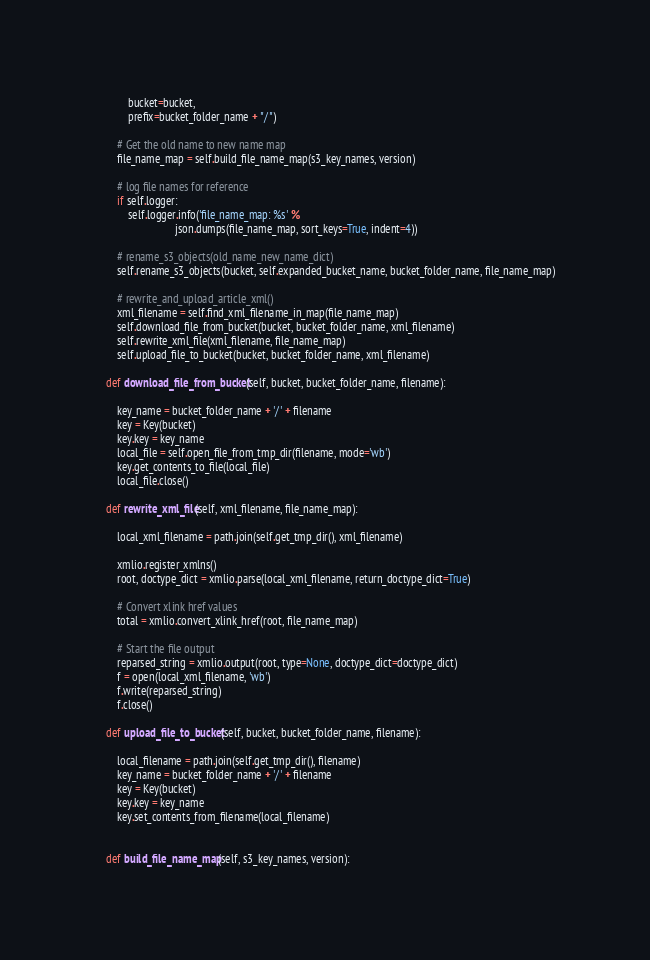<code> <loc_0><loc_0><loc_500><loc_500><_Python_>            bucket=bucket,
            prefix=bucket_folder_name + "/")

        # Get the old name to new name map
        file_name_map = self.build_file_name_map(s3_key_names, version)

        # log file names for reference
        if self.logger:
            self.logger.info('file_name_map: %s' %
                             json.dumps(file_name_map, sort_keys=True, indent=4))

        # rename_s3_objects(old_name_new_name_dict)
        self.rename_s3_objects(bucket, self.expanded_bucket_name, bucket_folder_name, file_name_map)

        # rewrite_and_upload_article_xml()
        xml_filename = self.find_xml_filename_in_map(file_name_map)
        self.download_file_from_bucket(bucket, bucket_folder_name, xml_filename)
        self.rewrite_xml_file(xml_filename, file_name_map)
        self.upload_file_to_bucket(bucket, bucket_folder_name, xml_filename)

    def download_file_from_bucket(self, bucket, bucket_folder_name, filename):

        key_name = bucket_folder_name + '/' + filename
        key = Key(bucket)
        key.key = key_name
        local_file = self.open_file_from_tmp_dir(filename, mode='wb')
        key.get_contents_to_file(local_file)
        local_file.close()

    def rewrite_xml_file(self, xml_filename, file_name_map):

        local_xml_filename = path.join(self.get_tmp_dir(), xml_filename)

        xmlio.register_xmlns()
        root, doctype_dict = xmlio.parse(local_xml_filename, return_doctype_dict=True)

        # Convert xlink href values
        total = xmlio.convert_xlink_href(root, file_name_map)

        # Start the file output
        reparsed_string = xmlio.output(root, type=None, doctype_dict=doctype_dict)
        f = open(local_xml_filename, 'wb')
        f.write(reparsed_string)
        f.close()

    def upload_file_to_bucket(self, bucket, bucket_folder_name, filename):

        local_filename = path.join(self.get_tmp_dir(), filename)
        key_name = bucket_folder_name + '/' + filename
        key = Key(bucket)
        key.key = key_name
        key.set_contents_from_filename(local_filename)


    def build_file_name_map(self, s3_key_names, version):
</code> 